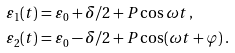<formula> <loc_0><loc_0><loc_500><loc_500>\varepsilon _ { 1 } ( t ) & = \varepsilon _ { 0 } + \delta / 2 + P \cos \omega t \, , \\ \varepsilon _ { 2 } ( t ) & = \varepsilon _ { 0 } - \delta / 2 + P \cos ( \omega t + \varphi ) \, .</formula> 